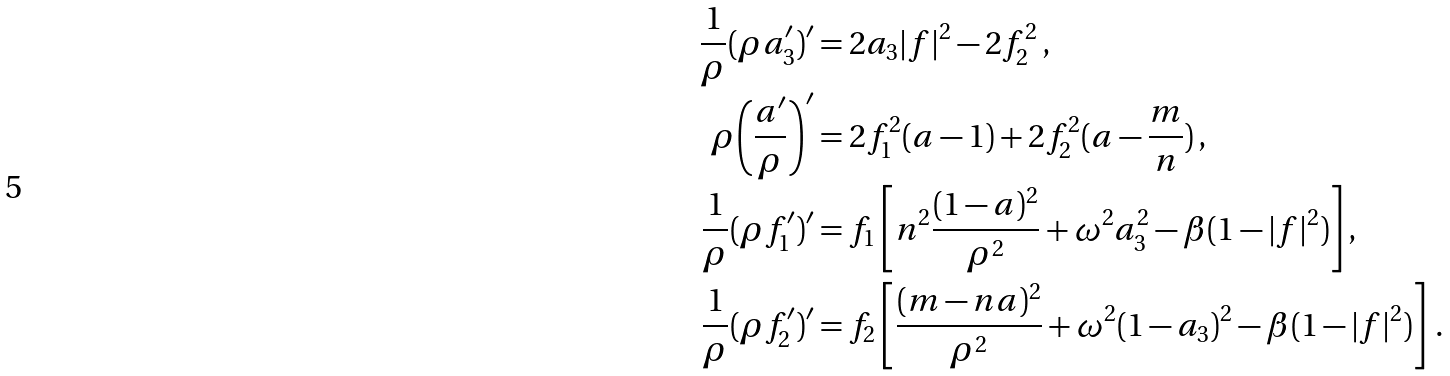Convert formula to latex. <formula><loc_0><loc_0><loc_500><loc_500>\frac { 1 } { \rho } ( \rho a _ { 3 } ^ { \prime } ) ^ { \prime } & = 2 a _ { 3 } | f | ^ { 2 } - 2 f _ { 2 } ^ { 2 } \, , \\ \rho { \left ( \frac { a ^ { \prime } } { \rho } \right ) } ^ { \prime } & = 2 f _ { 1 } ^ { 2 } ( a - 1 ) + 2 f _ { 2 } ^ { 2 } ( a - \frac { m } { n } ) \, , \\ \frac { 1 } { \rho } ( \rho f _ { 1 } ^ { \prime } ) ^ { \prime } & = f _ { 1 } \left [ n ^ { 2 } \frac { ( 1 - a ) ^ { 2 } } { \rho ^ { 2 } } + \omega ^ { 2 } a _ { 3 } ^ { 2 } - \beta ( 1 - | f | ^ { 2 } ) \right ] , \\ \frac { 1 } { \rho } ( \rho f _ { 2 } ^ { \prime } ) ^ { \prime } & = f _ { 2 } \left [ \frac { ( m - n a ) ^ { 2 } } { \rho ^ { 2 } } + \omega ^ { 2 } ( 1 - a _ { 3 } ) ^ { 2 } - \beta ( 1 - | f | ^ { 2 } ) \right ] \, .</formula> 